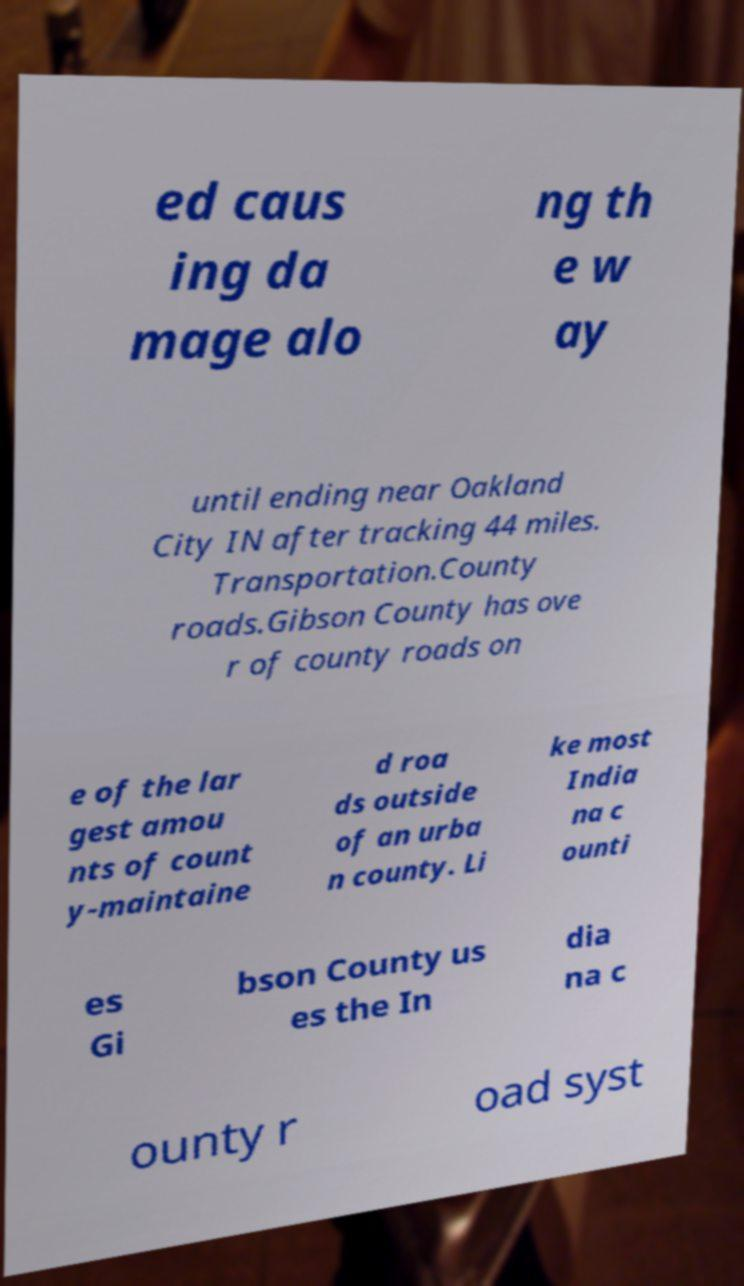Please identify and transcribe the text found in this image. ed caus ing da mage alo ng th e w ay until ending near Oakland City IN after tracking 44 miles. Transportation.County roads.Gibson County has ove r of county roads on e of the lar gest amou nts of count y-maintaine d roa ds outside of an urba n county. Li ke most India na c ounti es Gi bson County us es the In dia na c ounty r oad syst 